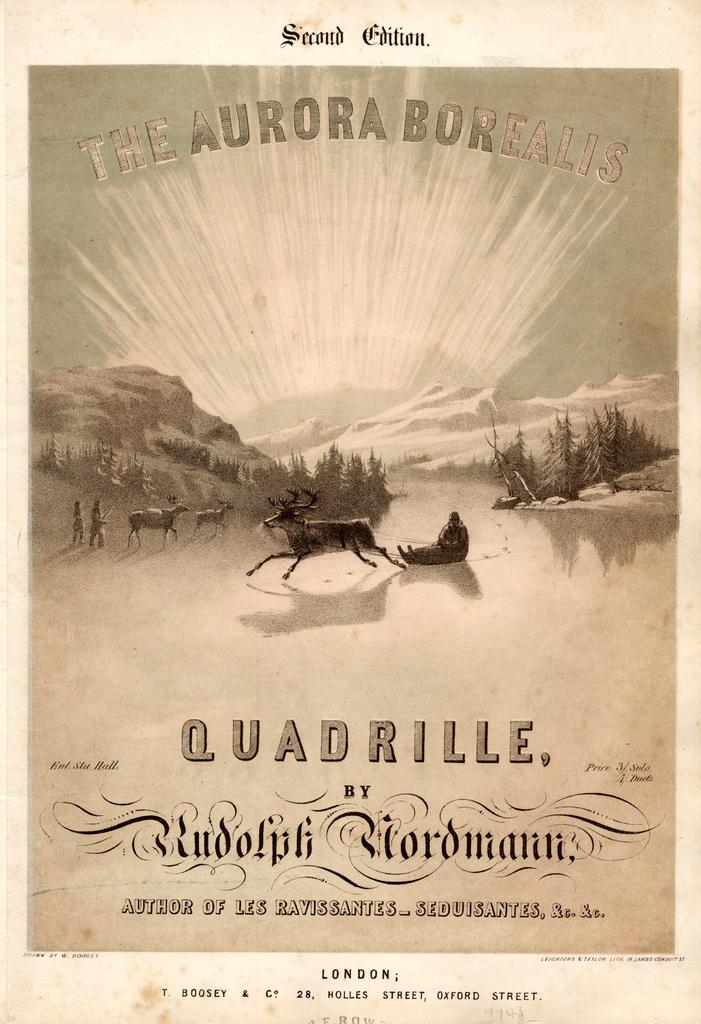<image>
Describe the image concisely. A book titled The Aurora Borealis Quadrille with a reindeer on the cover. 